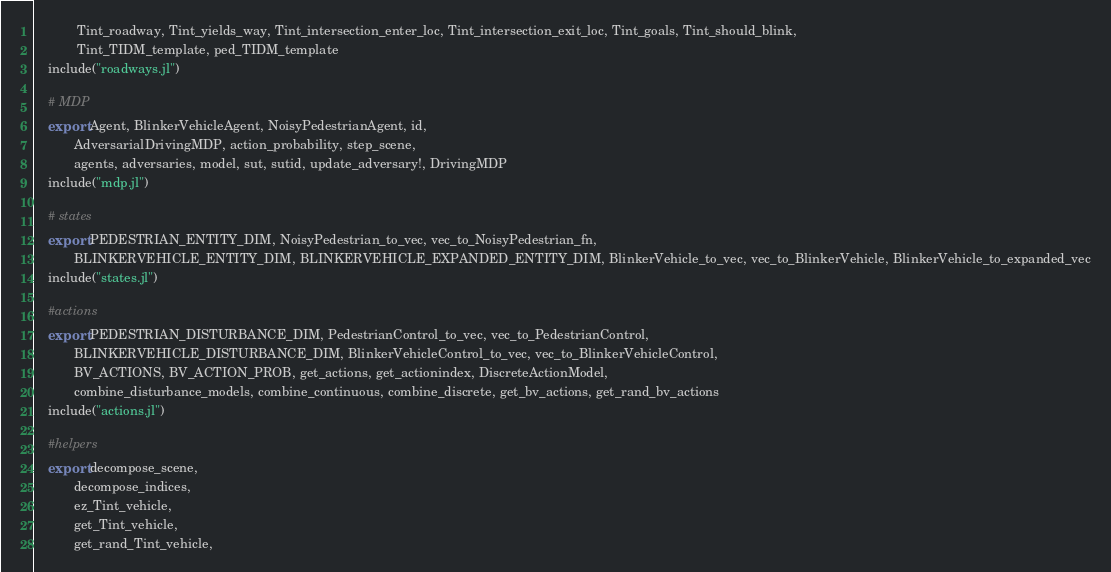Convert code to text. <code><loc_0><loc_0><loc_500><loc_500><_Julia_>            Tint_roadway, Tint_yields_way, Tint_intersection_enter_loc, Tint_intersection_exit_loc, Tint_goals, Tint_should_blink,
            Tint_TIDM_template, ped_TIDM_template
    include("roadways.jl")

    # MDP
    export Agent, BlinkerVehicleAgent, NoisyPedestrianAgent, id,
           AdversarialDrivingMDP, action_probability, step_scene,
           agents, adversaries, model, sut, sutid, update_adversary!, DrivingMDP
    include("mdp.jl")

    # states
    export PEDESTRIAN_ENTITY_DIM, NoisyPedestrian_to_vec, vec_to_NoisyPedestrian_fn,
           BLINKERVEHICLE_ENTITY_DIM, BLINKERVEHICLE_EXPANDED_ENTITY_DIM, BlinkerVehicle_to_vec, vec_to_BlinkerVehicle, BlinkerVehicle_to_expanded_vec
    include("states.jl")

    #actions
    export PEDESTRIAN_DISTURBANCE_DIM, PedestrianControl_to_vec, vec_to_PedestrianControl,
           BLINKERVEHICLE_DISTURBANCE_DIM, BlinkerVehicleControl_to_vec, vec_to_BlinkerVehicleControl,
           BV_ACTIONS, BV_ACTION_PROB, get_actions, get_actionindex, DiscreteActionModel,
           combine_disturbance_models, combine_continuous, combine_discrete, get_bv_actions, get_rand_bv_actions
    include("actions.jl")

    #helpers
    export decompose_scene,
           decompose_indices,
           ez_Tint_vehicle,
           get_Tint_vehicle,
           get_rand_Tint_vehicle,</code> 